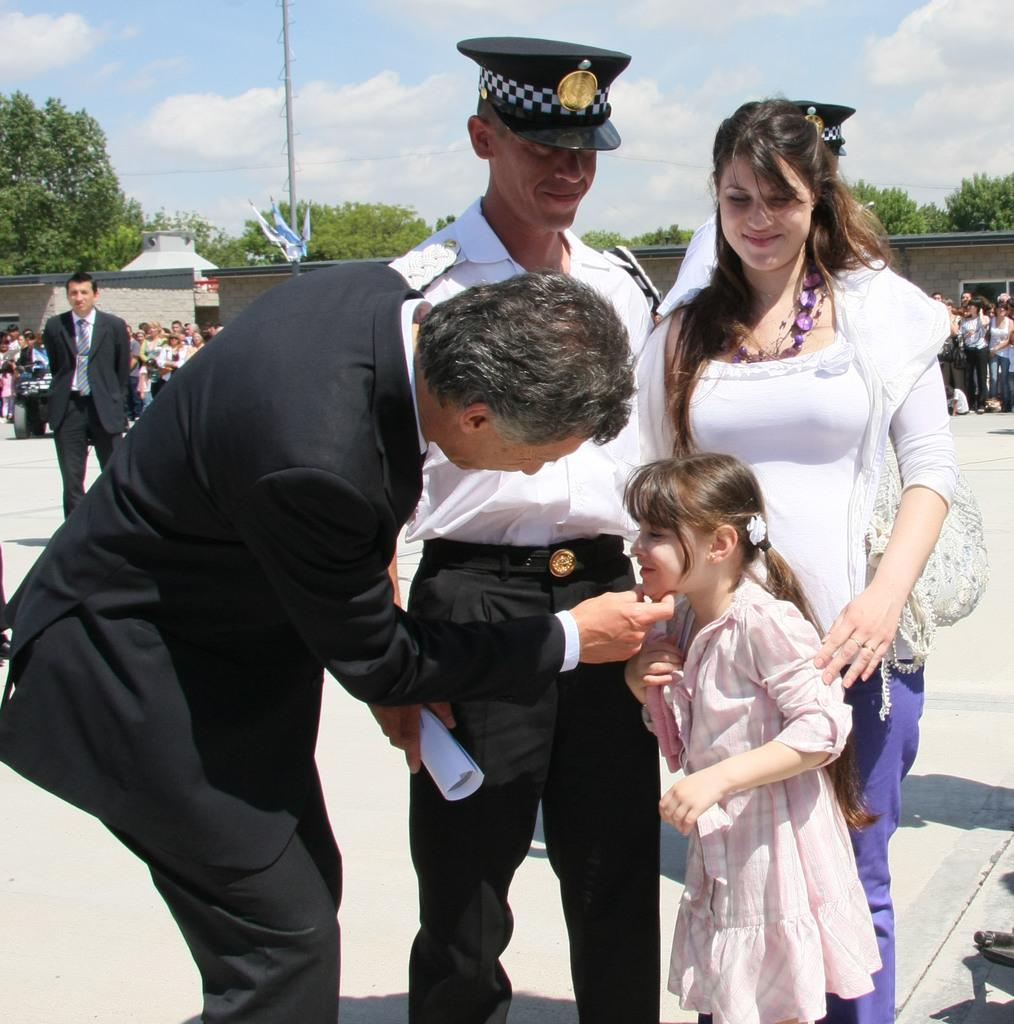How many people are present in the image? There are two men, a woman, and a girl in the image, making a total of four people. What are the people in the image doing? The people are standing on the ground and smiling. What can be seen in the background of the image? There is a group of people, a pole, trees, and the sky visible in the background of the image. What is the condition of the sky in the image? The sky is visible in the background of the image, and there are clouds present. How many locks can be seen on the pole in the image? There is no pole with locks present in the image; the pole mentioned in the facts is not associated with any locks. What type of beggar is present in the image? There is no beggar present in the image. 